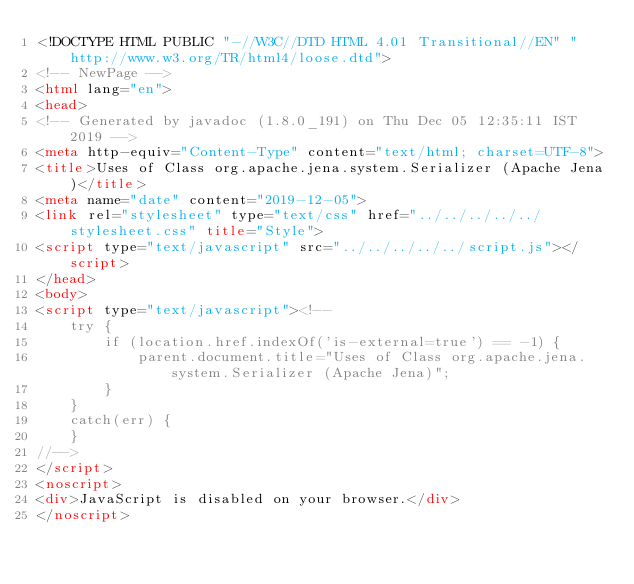<code> <loc_0><loc_0><loc_500><loc_500><_HTML_><!DOCTYPE HTML PUBLIC "-//W3C//DTD HTML 4.01 Transitional//EN" "http://www.w3.org/TR/html4/loose.dtd">
<!-- NewPage -->
<html lang="en">
<head>
<!-- Generated by javadoc (1.8.0_191) on Thu Dec 05 12:35:11 IST 2019 -->
<meta http-equiv="Content-Type" content="text/html; charset=UTF-8">
<title>Uses of Class org.apache.jena.system.Serializer (Apache Jena)</title>
<meta name="date" content="2019-12-05">
<link rel="stylesheet" type="text/css" href="../../../../../stylesheet.css" title="Style">
<script type="text/javascript" src="../../../../../script.js"></script>
</head>
<body>
<script type="text/javascript"><!--
    try {
        if (location.href.indexOf('is-external=true') == -1) {
            parent.document.title="Uses of Class org.apache.jena.system.Serializer (Apache Jena)";
        }
    }
    catch(err) {
    }
//-->
</script>
<noscript>
<div>JavaScript is disabled on your browser.</div>
</noscript></code> 